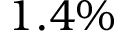<formula> <loc_0><loc_0><loc_500><loc_500>1 . 4 \%</formula> 